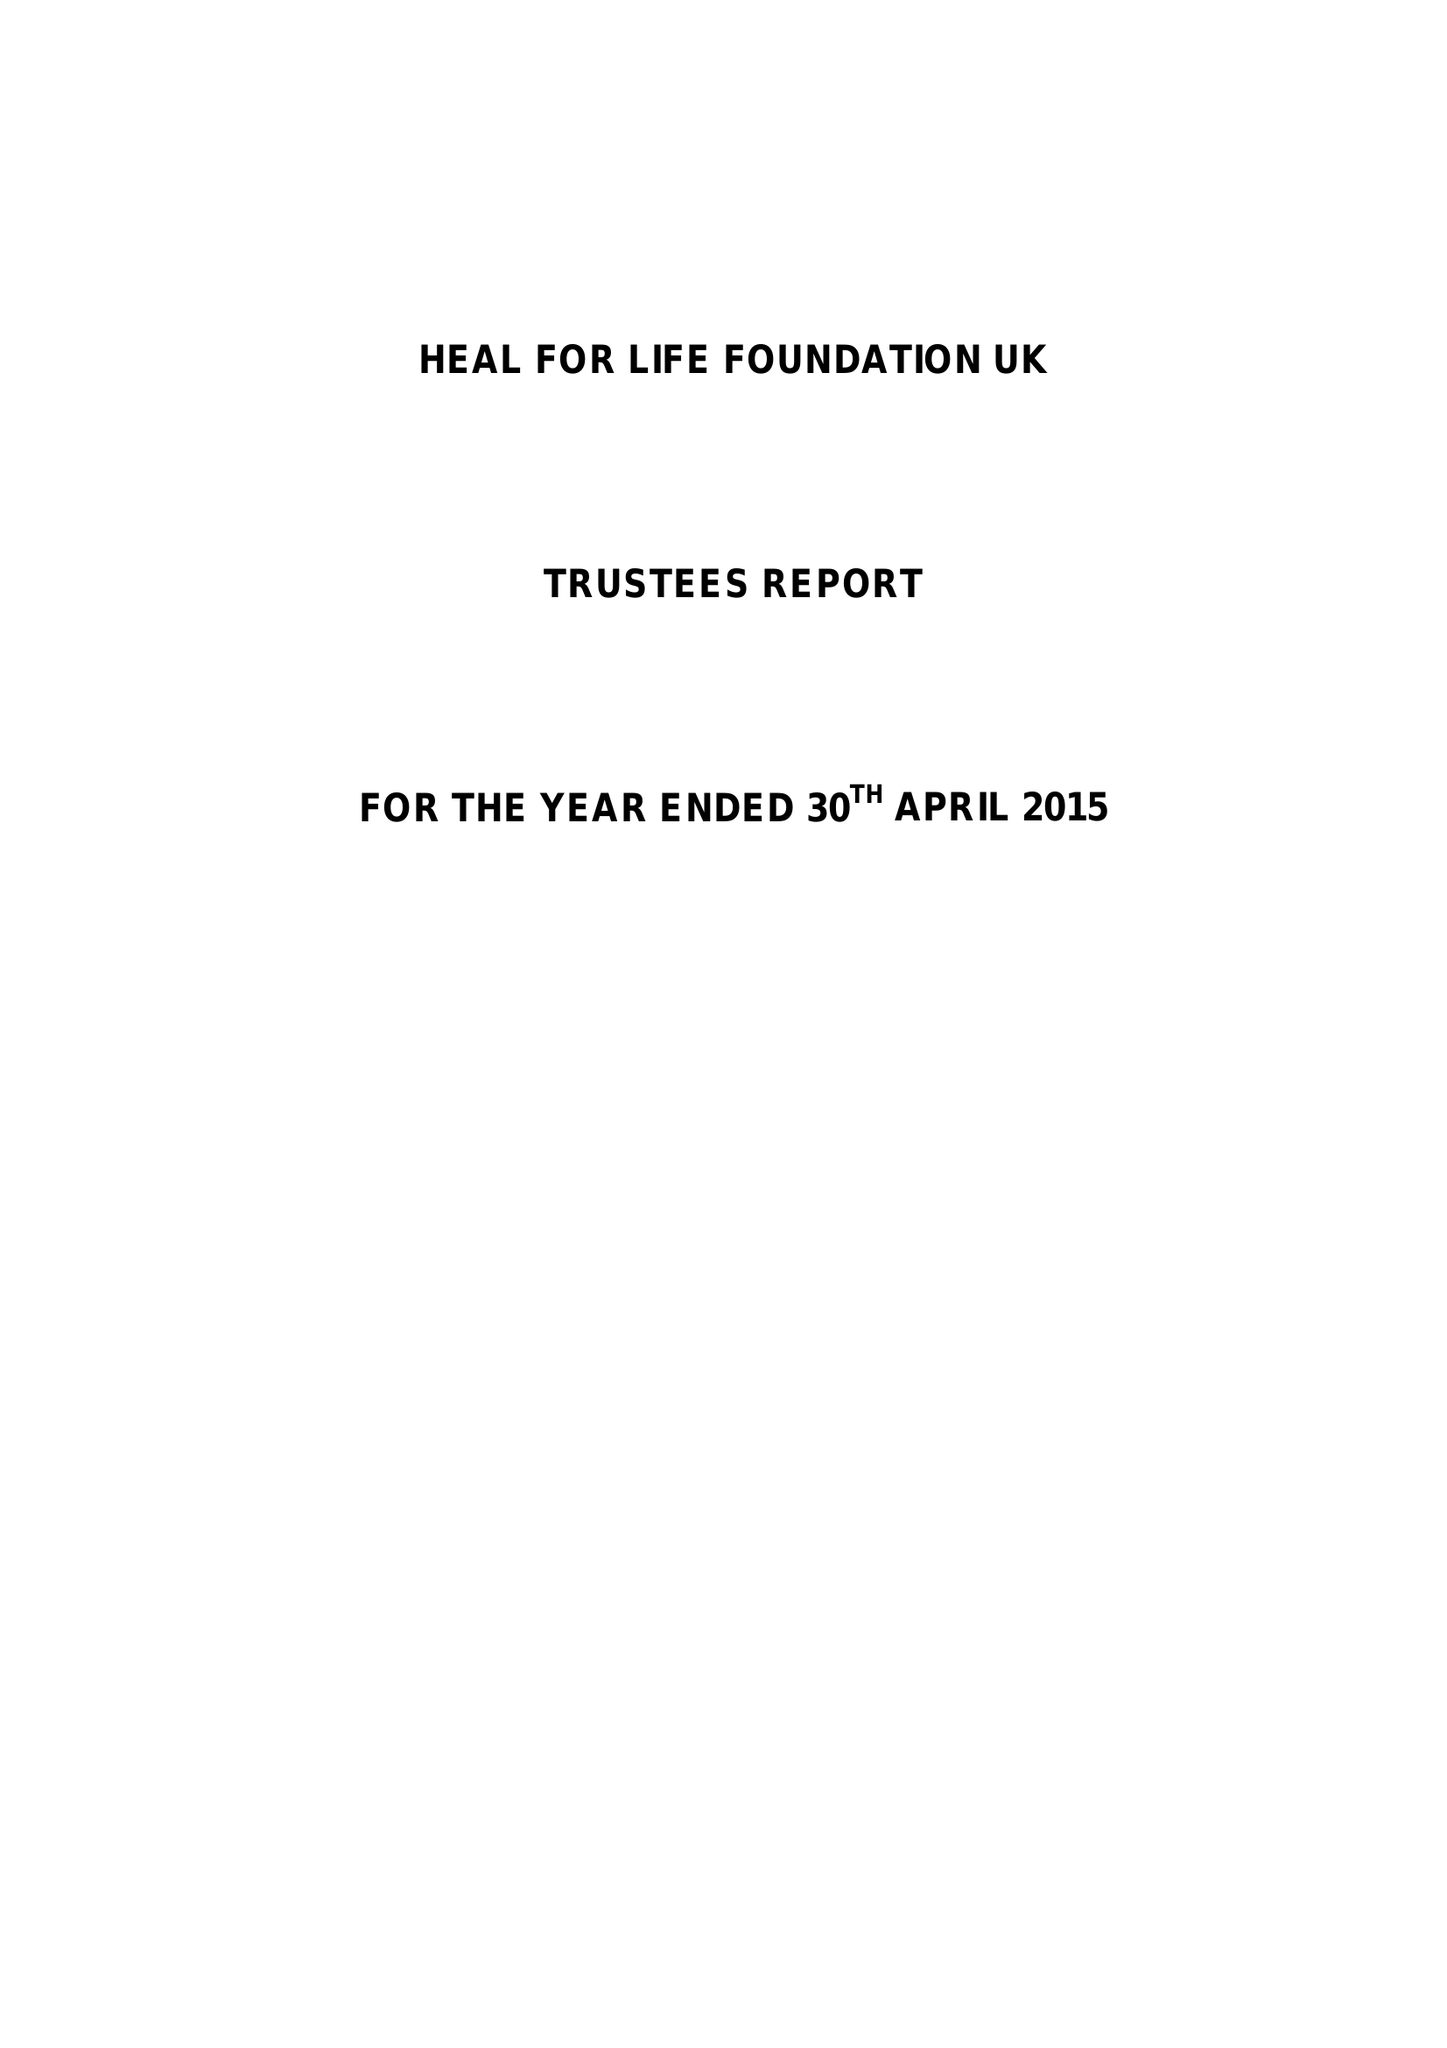What is the value for the address__postcode?
Answer the question using a single word or phrase. TN25 5BJ 